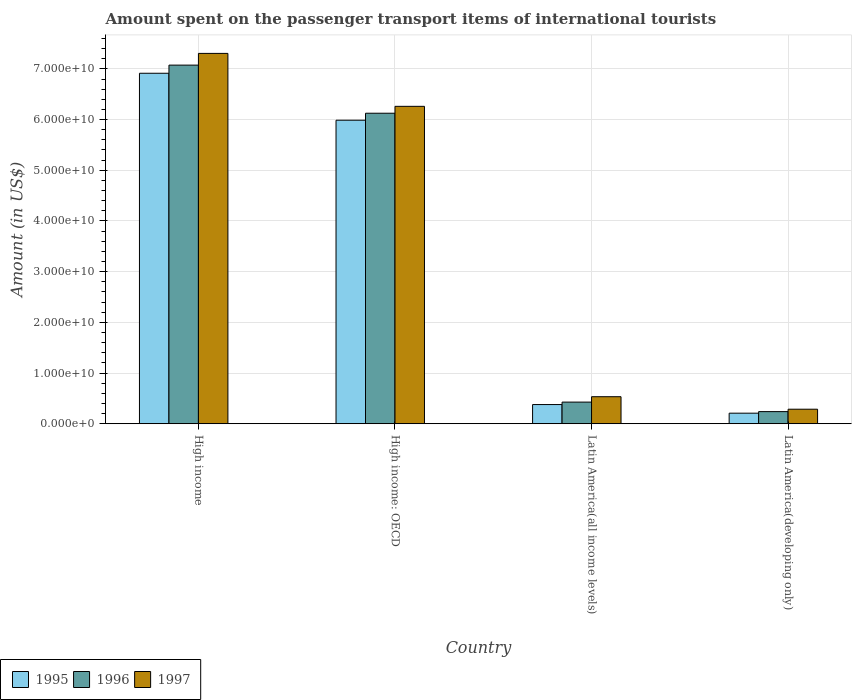How many different coloured bars are there?
Your answer should be very brief. 3. Are the number of bars per tick equal to the number of legend labels?
Give a very brief answer. Yes. How many bars are there on the 2nd tick from the right?
Give a very brief answer. 3. What is the label of the 4th group of bars from the left?
Give a very brief answer. Latin America(developing only). What is the amount spent on the passenger transport items of international tourists in 1997 in Latin America(developing only)?
Your response must be concise. 2.87e+09. Across all countries, what is the maximum amount spent on the passenger transport items of international tourists in 1997?
Provide a succinct answer. 7.31e+1. Across all countries, what is the minimum amount spent on the passenger transport items of international tourists in 1997?
Your response must be concise. 2.87e+09. In which country was the amount spent on the passenger transport items of international tourists in 1997 minimum?
Ensure brevity in your answer.  Latin America(developing only). What is the total amount spent on the passenger transport items of international tourists in 1995 in the graph?
Your response must be concise. 1.35e+11. What is the difference between the amount spent on the passenger transport items of international tourists in 1997 in Latin America(all income levels) and that in Latin America(developing only)?
Keep it short and to the point. 2.47e+09. What is the difference between the amount spent on the passenger transport items of international tourists in 1995 in Latin America(all income levels) and the amount spent on the passenger transport items of international tourists in 1997 in High income?
Offer a very short reply. -6.93e+1. What is the average amount spent on the passenger transport items of international tourists in 1995 per country?
Keep it short and to the point. 3.37e+1. What is the difference between the amount spent on the passenger transport items of international tourists of/in 1997 and amount spent on the passenger transport items of international tourists of/in 1996 in Latin America(developing only)?
Your response must be concise. 4.75e+08. What is the ratio of the amount spent on the passenger transport items of international tourists in 1995 in Latin America(all income levels) to that in Latin America(developing only)?
Your answer should be very brief. 1.82. Is the difference between the amount spent on the passenger transport items of international tourists in 1997 in High income and Latin America(all income levels) greater than the difference between the amount spent on the passenger transport items of international tourists in 1996 in High income and Latin America(all income levels)?
Provide a succinct answer. Yes. What is the difference between the highest and the second highest amount spent on the passenger transport items of international tourists in 1997?
Keep it short and to the point. 1.04e+1. What is the difference between the highest and the lowest amount spent on the passenger transport items of international tourists in 1997?
Your answer should be compact. 7.02e+1. In how many countries, is the amount spent on the passenger transport items of international tourists in 1996 greater than the average amount spent on the passenger transport items of international tourists in 1996 taken over all countries?
Ensure brevity in your answer.  2. Is the sum of the amount spent on the passenger transport items of international tourists in 1995 in High income: OECD and Latin America(all income levels) greater than the maximum amount spent on the passenger transport items of international tourists in 1997 across all countries?
Your answer should be very brief. No. How many bars are there?
Your response must be concise. 12. How many countries are there in the graph?
Your answer should be very brief. 4. What is the difference between two consecutive major ticks on the Y-axis?
Keep it short and to the point. 1.00e+1. Are the values on the major ticks of Y-axis written in scientific E-notation?
Keep it short and to the point. Yes. Does the graph contain grids?
Ensure brevity in your answer.  Yes. How many legend labels are there?
Provide a short and direct response. 3. What is the title of the graph?
Keep it short and to the point. Amount spent on the passenger transport items of international tourists. What is the label or title of the X-axis?
Keep it short and to the point. Country. What is the label or title of the Y-axis?
Your answer should be very brief. Amount (in US$). What is the Amount (in US$) in 1995 in High income?
Your answer should be compact. 6.91e+1. What is the Amount (in US$) of 1996 in High income?
Give a very brief answer. 7.07e+1. What is the Amount (in US$) of 1997 in High income?
Keep it short and to the point. 7.31e+1. What is the Amount (in US$) of 1995 in High income: OECD?
Provide a short and direct response. 5.99e+1. What is the Amount (in US$) of 1996 in High income: OECD?
Offer a terse response. 6.12e+1. What is the Amount (in US$) of 1997 in High income: OECD?
Make the answer very short. 6.26e+1. What is the Amount (in US$) in 1995 in Latin America(all income levels)?
Offer a very short reply. 3.79e+09. What is the Amount (in US$) of 1996 in Latin America(all income levels)?
Give a very brief answer. 4.27e+09. What is the Amount (in US$) of 1997 in Latin America(all income levels)?
Your answer should be compact. 5.33e+09. What is the Amount (in US$) of 1995 in Latin America(developing only)?
Offer a very short reply. 2.08e+09. What is the Amount (in US$) of 1996 in Latin America(developing only)?
Offer a terse response. 2.39e+09. What is the Amount (in US$) in 1997 in Latin America(developing only)?
Make the answer very short. 2.87e+09. Across all countries, what is the maximum Amount (in US$) in 1995?
Ensure brevity in your answer.  6.91e+1. Across all countries, what is the maximum Amount (in US$) of 1996?
Offer a very short reply. 7.07e+1. Across all countries, what is the maximum Amount (in US$) in 1997?
Your answer should be very brief. 7.31e+1. Across all countries, what is the minimum Amount (in US$) of 1995?
Provide a succinct answer. 2.08e+09. Across all countries, what is the minimum Amount (in US$) in 1996?
Provide a succinct answer. 2.39e+09. Across all countries, what is the minimum Amount (in US$) of 1997?
Your answer should be compact. 2.87e+09. What is the total Amount (in US$) of 1995 in the graph?
Keep it short and to the point. 1.35e+11. What is the total Amount (in US$) of 1996 in the graph?
Keep it short and to the point. 1.39e+11. What is the total Amount (in US$) of 1997 in the graph?
Provide a short and direct response. 1.44e+11. What is the difference between the Amount (in US$) of 1995 in High income and that in High income: OECD?
Make the answer very short. 9.26e+09. What is the difference between the Amount (in US$) of 1996 in High income and that in High income: OECD?
Ensure brevity in your answer.  9.49e+09. What is the difference between the Amount (in US$) in 1997 in High income and that in High income: OECD?
Offer a terse response. 1.04e+1. What is the difference between the Amount (in US$) of 1995 in High income and that in Latin America(all income levels)?
Make the answer very short. 6.53e+1. What is the difference between the Amount (in US$) in 1996 in High income and that in Latin America(all income levels)?
Offer a very short reply. 6.65e+1. What is the difference between the Amount (in US$) of 1997 in High income and that in Latin America(all income levels)?
Your answer should be very brief. 6.77e+1. What is the difference between the Amount (in US$) in 1995 in High income and that in Latin America(developing only)?
Offer a terse response. 6.70e+1. What is the difference between the Amount (in US$) of 1996 in High income and that in Latin America(developing only)?
Give a very brief answer. 6.83e+1. What is the difference between the Amount (in US$) in 1997 in High income and that in Latin America(developing only)?
Offer a terse response. 7.02e+1. What is the difference between the Amount (in US$) of 1995 in High income: OECD and that in Latin America(all income levels)?
Provide a succinct answer. 5.61e+1. What is the difference between the Amount (in US$) in 1996 in High income: OECD and that in Latin America(all income levels)?
Make the answer very short. 5.70e+1. What is the difference between the Amount (in US$) in 1997 in High income: OECD and that in Latin America(all income levels)?
Offer a terse response. 5.73e+1. What is the difference between the Amount (in US$) in 1995 in High income: OECD and that in Latin America(developing only)?
Make the answer very short. 5.78e+1. What is the difference between the Amount (in US$) in 1996 in High income: OECD and that in Latin America(developing only)?
Provide a succinct answer. 5.89e+1. What is the difference between the Amount (in US$) of 1997 in High income: OECD and that in Latin America(developing only)?
Your response must be concise. 5.97e+1. What is the difference between the Amount (in US$) in 1995 in Latin America(all income levels) and that in Latin America(developing only)?
Your answer should be very brief. 1.70e+09. What is the difference between the Amount (in US$) of 1996 in Latin America(all income levels) and that in Latin America(developing only)?
Offer a very short reply. 1.88e+09. What is the difference between the Amount (in US$) in 1997 in Latin America(all income levels) and that in Latin America(developing only)?
Offer a terse response. 2.47e+09. What is the difference between the Amount (in US$) of 1995 in High income and the Amount (in US$) of 1996 in High income: OECD?
Offer a very short reply. 7.88e+09. What is the difference between the Amount (in US$) of 1995 in High income and the Amount (in US$) of 1997 in High income: OECD?
Provide a succinct answer. 6.52e+09. What is the difference between the Amount (in US$) in 1996 in High income and the Amount (in US$) in 1997 in High income: OECD?
Make the answer very short. 8.13e+09. What is the difference between the Amount (in US$) in 1995 in High income and the Amount (in US$) in 1996 in Latin America(all income levels)?
Make the answer very short. 6.49e+1. What is the difference between the Amount (in US$) of 1995 in High income and the Amount (in US$) of 1997 in Latin America(all income levels)?
Keep it short and to the point. 6.38e+1. What is the difference between the Amount (in US$) in 1996 in High income and the Amount (in US$) in 1997 in Latin America(all income levels)?
Offer a terse response. 6.54e+1. What is the difference between the Amount (in US$) of 1995 in High income and the Amount (in US$) of 1996 in Latin America(developing only)?
Ensure brevity in your answer.  6.67e+1. What is the difference between the Amount (in US$) in 1995 in High income and the Amount (in US$) in 1997 in Latin America(developing only)?
Your answer should be compact. 6.63e+1. What is the difference between the Amount (in US$) of 1996 in High income and the Amount (in US$) of 1997 in Latin America(developing only)?
Offer a very short reply. 6.79e+1. What is the difference between the Amount (in US$) of 1995 in High income: OECD and the Amount (in US$) of 1996 in Latin America(all income levels)?
Provide a succinct answer. 5.56e+1. What is the difference between the Amount (in US$) in 1995 in High income: OECD and the Amount (in US$) in 1997 in Latin America(all income levels)?
Ensure brevity in your answer.  5.45e+1. What is the difference between the Amount (in US$) in 1996 in High income: OECD and the Amount (in US$) in 1997 in Latin America(all income levels)?
Ensure brevity in your answer.  5.59e+1. What is the difference between the Amount (in US$) of 1995 in High income: OECD and the Amount (in US$) of 1996 in Latin America(developing only)?
Give a very brief answer. 5.75e+1. What is the difference between the Amount (in US$) in 1995 in High income: OECD and the Amount (in US$) in 1997 in Latin America(developing only)?
Your answer should be very brief. 5.70e+1. What is the difference between the Amount (in US$) in 1996 in High income: OECD and the Amount (in US$) in 1997 in Latin America(developing only)?
Offer a terse response. 5.84e+1. What is the difference between the Amount (in US$) in 1995 in Latin America(all income levels) and the Amount (in US$) in 1996 in Latin America(developing only)?
Provide a short and direct response. 1.39e+09. What is the difference between the Amount (in US$) of 1995 in Latin America(all income levels) and the Amount (in US$) of 1997 in Latin America(developing only)?
Offer a very short reply. 9.19e+08. What is the difference between the Amount (in US$) in 1996 in Latin America(all income levels) and the Amount (in US$) in 1997 in Latin America(developing only)?
Give a very brief answer. 1.40e+09. What is the average Amount (in US$) in 1995 per country?
Your answer should be compact. 3.37e+1. What is the average Amount (in US$) in 1996 per country?
Provide a succinct answer. 3.47e+1. What is the average Amount (in US$) in 1997 per country?
Provide a succinct answer. 3.60e+1. What is the difference between the Amount (in US$) in 1995 and Amount (in US$) in 1996 in High income?
Keep it short and to the point. -1.61e+09. What is the difference between the Amount (in US$) in 1995 and Amount (in US$) in 1997 in High income?
Your response must be concise. -3.92e+09. What is the difference between the Amount (in US$) in 1996 and Amount (in US$) in 1997 in High income?
Your response must be concise. -2.31e+09. What is the difference between the Amount (in US$) of 1995 and Amount (in US$) of 1996 in High income: OECD?
Offer a very short reply. -1.38e+09. What is the difference between the Amount (in US$) in 1995 and Amount (in US$) in 1997 in High income: OECD?
Offer a terse response. -2.74e+09. What is the difference between the Amount (in US$) in 1996 and Amount (in US$) in 1997 in High income: OECD?
Offer a terse response. -1.36e+09. What is the difference between the Amount (in US$) in 1995 and Amount (in US$) in 1996 in Latin America(all income levels)?
Your answer should be very brief. -4.84e+08. What is the difference between the Amount (in US$) in 1995 and Amount (in US$) in 1997 in Latin America(all income levels)?
Your answer should be very brief. -1.55e+09. What is the difference between the Amount (in US$) of 1996 and Amount (in US$) of 1997 in Latin America(all income levels)?
Give a very brief answer. -1.06e+09. What is the difference between the Amount (in US$) of 1995 and Amount (in US$) of 1996 in Latin America(developing only)?
Your answer should be compact. -3.07e+08. What is the difference between the Amount (in US$) of 1995 and Amount (in US$) of 1997 in Latin America(developing only)?
Your answer should be very brief. -7.82e+08. What is the difference between the Amount (in US$) in 1996 and Amount (in US$) in 1997 in Latin America(developing only)?
Give a very brief answer. -4.75e+08. What is the ratio of the Amount (in US$) in 1995 in High income to that in High income: OECD?
Your answer should be very brief. 1.15. What is the ratio of the Amount (in US$) of 1996 in High income to that in High income: OECD?
Make the answer very short. 1.15. What is the ratio of the Amount (in US$) in 1997 in High income to that in High income: OECD?
Offer a very short reply. 1.17. What is the ratio of the Amount (in US$) in 1995 in High income to that in Latin America(all income levels)?
Your answer should be very brief. 18.26. What is the ratio of the Amount (in US$) in 1996 in High income to that in Latin America(all income levels)?
Your answer should be compact. 16.57. What is the ratio of the Amount (in US$) in 1997 in High income to that in Latin America(all income levels)?
Offer a very short reply. 13.7. What is the ratio of the Amount (in US$) in 1995 in High income to that in Latin America(developing only)?
Ensure brevity in your answer.  33.17. What is the ratio of the Amount (in US$) of 1996 in High income to that in Latin America(developing only)?
Your answer should be very brief. 29.58. What is the ratio of the Amount (in US$) in 1997 in High income to that in Latin America(developing only)?
Keep it short and to the point. 25.49. What is the ratio of the Amount (in US$) of 1995 in High income: OECD to that in Latin America(all income levels)?
Provide a succinct answer. 15.82. What is the ratio of the Amount (in US$) in 1996 in High income: OECD to that in Latin America(all income levels)?
Ensure brevity in your answer.  14.35. What is the ratio of the Amount (in US$) in 1997 in High income: OECD to that in Latin America(all income levels)?
Provide a succinct answer. 11.74. What is the ratio of the Amount (in US$) in 1995 in High income: OECD to that in Latin America(developing only)?
Provide a succinct answer. 28.72. What is the ratio of the Amount (in US$) of 1996 in High income: OECD to that in Latin America(developing only)?
Your response must be concise. 25.61. What is the ratio of the Amount (in US$) of 1997 in High income: OECD to that in Latin America(developing only)?
Provide a short and direct response. 21.84. What is the ratio of the Amount (in US$) of 1995 in Latin America(all income levels) to that in Latin America(developing only)?
Give a very brief answer. 1.82. What is the ratio of the Amount (in US$) in 1996 in Latin America(all income levels) to that in Latin America(developing only)?
Your answer should be compact. 1.79. What is the ratio of the Amount (in US$) in 1997 in Latin America(all income levels) to that in Latin America(developing only)?
Your answer should be compact. 1.86. What is the difference between the highest and the second highest Amount (in US$) in 1995?
Ensure brevity in your answer.  9.26e+09. What is the difference between the highest and the second highest Amount (in US$) in 1996?
Make the answer very short. 9.49e+09. What is the difference between the highest and the second highest Amount (in US$) in 1997?
Keep it short and to the point. 1.04e+1. What is the difference between the highest and the lowest Amount (in US$) in 1995?
Provide a short and direct response. 6.70e+1. What is the difference between the highest and the lowest Amount (in US$) in 1996?
Offer a very short reply. 6.83e+1. What is the difference between the highest and the lowest Amount (in US$) of 1997?
Provide a succinct answer. 7.02e+1. 